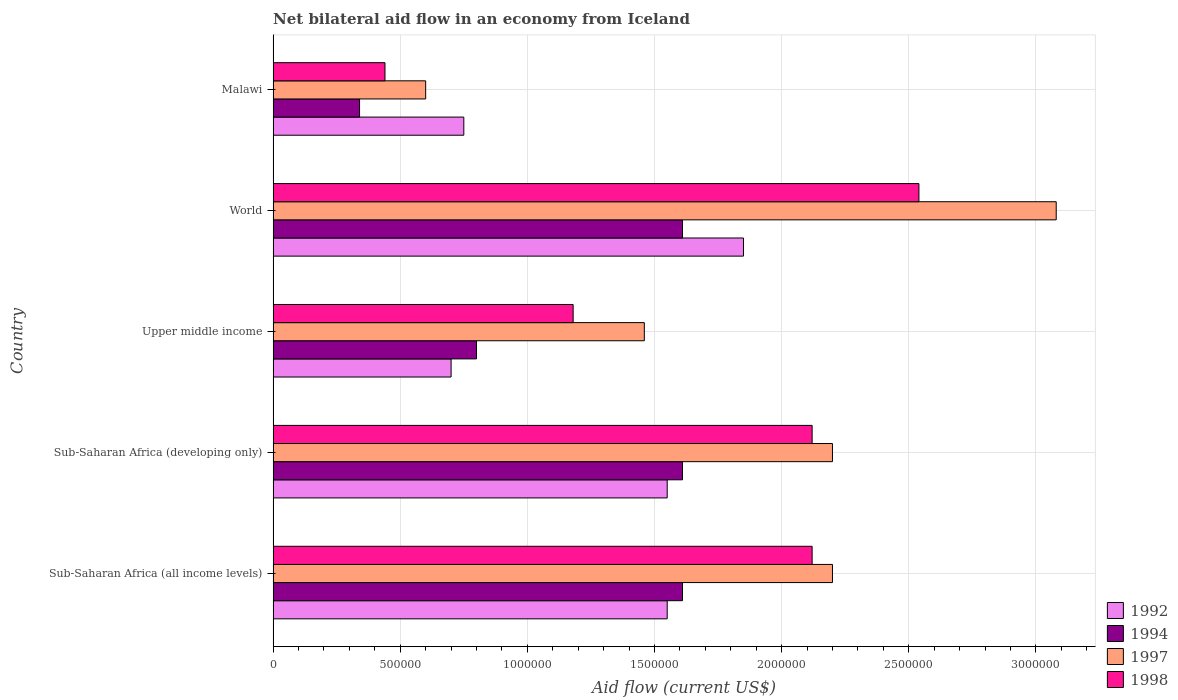How many bars are there on the 5th tick from the top?
Make the answer very short. 4. What is the label of the 4th group of bars from the top?
Offer a very short reply. Sub-Saharan Africa (developing only). Across all countries, what is the maximum net bilateral aid flow in 1998?
Your answer should be compact. 2.54e+06. In which country was the net bilateral aid flow in 1992 minimum?
Keep it short and to the point. Upper middle income. What is the total net bilateral aid flow in 1997 in the graph?
Your response must be concise. 9.54e+06. What is the difference between the net bilateral aid flow in 1998 in Sub-Saharan Africa (developing only) and that in Upper middle income?
Offer a very short reply. 9.40e+05. What is the difference between the net bilateral aid flow in 1997 in Malawi and the net bilateral aid flow in 1992 in World?
Keep it short and to the point. -1.25e+06. What is the average net bilateral aid flow in 1994 per country?
Ensure brevity in your answer.  1.19e+06. In how many countries, is the net bilateral aid flow in 1992 greater than 2400000 US$?
Offer a terse response. 0. What is the ratio of the net bilateral aid flow in 1997 in Malawi to that in Sub-Saharan Africa (developing only)?
Your answer should be very brief. 0.27. Is the net bilateral aid flow in 1997 in Malawi less than that in Sub-Saharan Africa (developing only)?
Offer a terse response. Yes. What is the difference between the highest and the second highest net bilateral aid flow in 1992?
Your answer should be very brief. 3.00e+05. What is the difference between the highest and the lowest net bilateral aid flow in 1994?
Offer a terse response. 1.27e+06. Is it the case that in every country, the sum of the net bilateral aid flow in 1998 and net bilateral aid flow in 1992 is greater than the net bilateral aid flow in 1994?
Ensure brevity in your answer.  Yes. How many countries are there in the graph?
Give a very brief answer. 5. What is the difference between two consecutive major ticks on the X-axis?
Ensure brevity in your answer.  5.00e+05. Are the values on the major ticks of X-axis written in scientific E-notation?
Offer a very short reply. No. Does the graph contain any zero values?
Offer a very short reply. No. How many legend labels are there?
Keep it short and to the point. 4. How are the legend labels stacked?
Your answer should be compact. Vertical. What is the title of the graph?
Offer a terse response. Net bilateral aid flow in an economy from Iceland. What is the label or title of the Y-axis?
Your answer should be very brief. Country. What is the Aid flow (current US$) of 1992 in Sub-Saharan Africa (all income levels)?
Give a very brief answer. 1.55e+06. What is the Aid flow (current US$) in 1994 in Sub-Saharan Africa (all income levels)?
Make the answer very short. 1.61e+06. What is the Aid flow (current US$) of 1997 in Sub-Saharan Africa (all income levels)?
Provide a succinct answer. 2.20e+06. What is the Aid flow (current US$) of 1998 in Sub-Saharan Africa (all income levels)?
Make the answer very short. 2.12e+06. What is the Aid flow (current US$) of 1992 in Sub-Saharan Africa (developing only)?
Offer a terse response. 1.55e+06. What is the Aid flow (current US$) of 1994 in Sub-Saharan Africa (developing only)?
Your response must be concise. 1.61e+06. What is the Aid flow (current US$) of 1997 in Sub-Saharan Africa (developing only)?
Provide a succinct answer. 2.20e+06. What is the Aid flow (current US$) of 1998 in Sub-Saharan Africa (developing only)?
Your answer should be compact. 2.12e+06. What is the Aid flow (current US$) of 1997 in Upper middle income?
Provide a succinct answer. 1.46e+06. What is the Aid flow (current US$) in 1998 in Upper middle income?
Make the answer very short. 1.18e+06. What is the Aid flow (current US$) in 1992 in World?
Offer a terse response. 1.85e+06. What is the Aid flow (current US$) of 1994 in World?
Provide a short and direct response. 1.61e+06. What is the Aid flow (current US$) of 1997 in World?
Your answer should be compact. 3.08e+06. What is the Aid flow (current US$) of 1998 in World?
Provide a short and direct response. 2.54e+06. What is the Aid flow (current US$) in 1992 in Malawi?
Ensure brevity in your answer.  7.50e+05. Across all countries, what is the maximum Aid flow (current US$) in 1992?
Ensure brevity in your answer.  1.85e+06. Across all countries, what is the maximum Aid flow (current US$) in 1994?
Ensure brevity in your answer.  1.61e+06. Across all countries, what is the maximum Aid flow (current US$) in 1997?
Your answer should be compact. 3.08e+06. Across all countries, what is the maximum Aid flow (current US$) in 1998?
Offer a very short reply. 2.54e+06. Across all countries, what is the minimum Aid flow (current US$) of 1992?
Provide a succinct answer. 7.00e+05. Across all countries, what is the minimum Aid flow (current US$) of 1994?
Ensure brevity in your answer.  3.40e+05. Across all countries, what is the minimum Aid flow (current US$) in 1997?
Provide a succinct answer. 6.00e+05. Across all countries, what is the minimum Aid flow (current US$) in 1998?
Your answer should be compact. 4.40e+05. What is the total Aid flow (current US$) in 1992 in the graph?
Provide a short and direct response. 6.40e+06. What is the total Aid flow (current US$) of 1994 in the graph?
Offer a very short reply. 5.97e+06. What is the total Aid flow (current US$) in 1997 in the graph?
Your response must be concise. 9.54e+06. What is the total Aid flow (current US$) of 1998 in the graph?
Keep it short and to the point. 8.40e+06. What is the difference between the Aid flow (current US$) of 1992 in Sub-Saharan Africa (all income levels) and that in Sub-Saharan Africa (developing only)?
Your answer should be compact. 0. What is the difference between the Aid flow (current US$) of 1994 in Sub-Saharan Africa (all income levels) and that in Sub-Saharan Africa (developing only)?
Provide a short and direct response. 0. What is the difference between the Aid flow (current US$) in 1997 in Sub-Saharan Africa (all income levels) and that in Sub-Saharan Africa (developing only)?
Offer a very short reply. 0. What is the difference between the Aid flow (current US$) in 1998 in Sub-Saharan Africa (all income levels) and that in Sub-Saharan Africa (developing only)?
Keep it short and to the point. 0. What is the difference between the Aid flow (current US$) of 1992 in Sub-Saharan Africa (all income levels) and that in Upper middle income?
Ensure brevity in your answer.  8.50e+05. What is the difference between the Aid flow (current US$) in 1994 in Sub-Saharan Africa (all income levels) and that in Upper middle income?
Your answer should be very brief. 8.10e+05. What is the difference between the Aid flow (current US$) of 1997 in Sub-Saharan Africa (all income levels) and that in Upper middle income?
Provide a succinct answer. 7.40e+05. What is the difference between the Aid flow (current US$) in 1998 in Sub-Saharan Africa (all income levels) and that in Upper middle income?
Make the answer very short. 9.40e+05. What is the difference between the Aid flow (current US$) of 1992 in Sub-Saharan Africa (all income levels) and that in World?
Make the answer very short. -3.00e+05. What is the difference between the Aid flow (current US$) of 1997 in Sub-Saharan Africa (all income levels) and that in World?
Provide a succinct answer. -8.80e+05. What is the difference between the Aid flow (current US$) of 1998 in Sub-Saharan Africa (all income levels) and that in World?
Give a very brief answer. -4.20e+05. What is the difference between the Aid flow (current US$) in 1992 in Sub-Saharan Africa (all income levels) and that in Malawi?
Offer a very short reply. 8.00e+05. What is the difference between the Aid flow (current US$) of 1994 in Sub-Saharan Africa (all income levels) and that in Malawi?
Give a very brief answer. 1.27e+06. What is the difference between the Aid flow (current US$) of 1997 in Sub-Saharan Africa (all income levels) and that in Malawi?
Offer a very short reply. 1.60e+06. What is the difference between the Aid flow (current US$) in 1998 in Sub-Saharan Africa (all income levels) and that in Malawi?
Offer a terse response. 1.68e+06. What is the difference between the Aid flow (current US$) in 1992 in Sub-Saharan Africa (developing only) and that in Upper middle income?
Your answer should be compact. 8.50e+05. What is the difference between the Aid flow (current US$) in 1994 in Sub-Saharan Africa (developing only) and that in Upper middle income?
Make the answer very short. 8.10e+05. What is the difference between the Aid flow (current US$) of 1997 in Sub-Saharan Africa (developing only) and that in Upper middle income?
Your answer should be compact. 7.40e+05. What is the difference between the Aid flow (current US$) of 1998 in Sub-Saharan Africa (developing only) and that in Upper middle income?
Keep it short and to the point. 9.40e+05. What is the difference between the Aid flow (current US$) in 1992 in Sub-Saharan Africa (developing only) and that in World?
Your answer should be compact. -3.00e+05. What is the difference between the Aid flow (current US$) in 1997 in Sub-Saharan Africa (developing only) and that in World?
Your answer should be very brief. -8.80e+05. What is the difference between the Aid flow (current US$) in 1998 in Sub-Saharan Africa (developing only) and that in World?
Your answer should be very brief. -4.20e+05. What is the difference between the Aid flow (current US$) in 1994 in Sub-Saharan Africa (developing only) and that in Malawi?
Your answer should be very brief. 1.27e+06. What is the difference between the Aid flow (current US$) of 1997 in Sub-Saharan Africa (developing only) and that in Malawi?
Offer a very short reply. 1.60e+06. What is the difference between the Aid flow (current US$) of 1998 in Sub-Saharan Africa (developing only) and that in Malawi?
Make the answer very short. 1.68e+06. What is the difference between the Aid flow (current US$) of 1992 in Upper middle income and that in World?
Your answer should be very brief. -1.15e+06. What is the difference between the Aid flow (current US$) in 1994 in Upper middle income and that in World?
Offer a terse response. -8.10e+05. What is the difference between the Aid flow (current US$) in 1997 in Upper middle income and that in World?
Provide a short and direct response. -1.62e+06. What is the difference between the Aid flow (current US$) of 1998 in Upper middle income and that in World?
Offer a very short reply. -1.36e+06. What is the difference between the Aid flow (current US$) in 1992 in Upper middle income and that in Malawi?
Provide a short and direct response. -5.00e+04. What is the difference between the Aid flow (current US$) in 1994 in Upper middle income and that in Malawi?
Your response must be concise. 4.60e+05. What is the difference between the Aid flow (current US$) in 1997 in Upper middle income and that in Malawi?
Give a very brief answer. 8.60e+05. What is the difference between the Aid flow (current US$) in 1998 in Upper middle income and that in Malawi?
Your answer should be compact. 7.40e+05. What is the difference between the Aid flow (current US$) of 1992 in World and that in Malawi?
Offer a very short reply. 1.10e+06. What is the difference between the Aid flow (current US$) in 1994 in World and that in Malawi?
Your answer should be compact. 1.27e+06. What is the difference between the Aid flow (current US$) in 1997 in World and that in Malawi?
Keep it short and to the point. 2.48e+06. What is the difference between the Aid flow (current US$) in 1998 in World and that in Malawi?
Your answer should be compact. 2.10e+06. What is the difference between the Aid flow (current US$) in 1992 in Sub-Saharan Africa (all income levels) and the Aid flow (current US$) in 1994 in Sub-Saharan Africa (developing only)?
Provide a short and direct response. -6.00e+04. What is the difference between the Aid flow (current US$) in 1992 in Sub-Saharan Africa (all income levels) and the Aid flow (current US$) in 1997 in Sub-Saharan Africa (developing only)?
Your answer should be very brief. -6.50e+05. What is the difference between the Aid flow (current US$) of 1992 in Sub-Saharan Africa (all income levels) and the Aid flow (current US$) of 1998 in Sub-Saharan Africa (developing only)?
Offer a terse response. -5.70e+05. What is the difference between the Aid flow (current US$) of 1994 in Sub-Saharan Africa (all income levels) and the Aid flow (current US$) of 1997 in Sub-Saharan Africa (developing only)?
Your answer should be compact. -5.90e+05. What is the difference between the Aid flow (current US$) of 1994 in Sub-Saharan Africa (all income levels) and the Aid flow (current US$) of 1998 in Sub-Saharan Africa (developing only)?
Provide a short and direct response. -5.10e+05. What is the difference between the Aid flow (current US$) in 1992 in Sub-Saharan Africa (all income levels) and the Aid flow (current US$) in 1994 in Upper middle income?
Offer a terse response. 7.50e+05. What is the difference between the Aid flow (current US$) of 1992 in Sub-Saharan Africa (all income levels) and the Aid flow (current US$) of 1997 in Upper middle income?
Ensure brevity in your answer.  9.00e+04. What is the difference between the Aid flow (current US$) in 1992 in Sub-Saharan Africa (all income levels) and the Aid flow (current US$) in 1998 in Upper middle income?
Provide a succinct answer. 3.70e+05. What is the difference between the Aid flow (current US$) in 1997 in Sub-Saharan Africa (all income levels) and the Aid flow (current US$) in 1998 in Upper middle income?
Provide a succinct answer. 1.02e+06. What is the difference between the Aid flow (current US$) in 1992 in Sub-Saharan Africa (all income levels) and the Aid flow (current US$) in 1997 in World?
Your answer should be very brief. -1.53e+06. What is the difference between the Aid flow (current US$) in 1992 in Sub-Saharan Africa (all income levels) and the Aid flow (current US$) in 1998 in World?
Your answer should be compact. -9.90e+05. What is the difference between the Aid flow (current US$) in 1994 in Sub-Saharan Africa (all income levels) and the Aid flow (current US$) in 1997 in World?
Your response must be concise. -1.47e+06. What is the difference between the Aid flow (current US$) in 1994 in Sub-Saharan Africa (all income levels) and the Aid flow (current US$) in 1998 in World?
Provide a succinct answer. -9.30e+05. What is the difference between the Aid flow (current US$) of 1992 in Sub-Saharan Africa (all income levels) and the Aid flow (current US$) of 1994 in Malawi?
Your answer should be very brief. 1.21e+06. What is the difference between the Aid flow (current US$) in 1992 in Sub-Saharan Africa (all income levels) and the Aid flow (current US$) in 1997 in Malawi?
Your response must be concise. 9.50e+05. What is the difference between the Aid flow (current US$) in 1992 in Sub-Saharan Africa (all income levels) and the Aid flow (current US$) in 1998 in Malawi?
Your answer should be compact. 1.11e+06. What is the difference between the Aid flow (current US$) of 1994 in Sub-Saharan Africa (all income levels) and the Aid flow (current US$) of 1997 in Malawi?
Your answer should be very brief. 1.01e+06. What is the difference between the Aid flow (current US$) in 1994 in Sub-Saharan Africa (all income levels) and the Aid flow (current US$) in 1998 in Malawi?
Your response must be concise. 1.17e+06. What is the difference between the Aid flow (current US$) of 1997 in Sub-Saharan Africa (all income levels) and the Aid flow (current US$) of 1998 in Malawi?
Provide a succinct answer. 1.76e+06. What is the difference between the Aid flow (current US$) in 1992 in Sub-Saharan Africa (developing only) and the Aid flow (current US$) in 1994 in Upper middle income?
Keep it short and to the point. 7.50e+05. What is the difference between the Aid flow (current US$) in 1992 in Sub-Saharan Africa (developing only) and the Aid flow (current US$) in 1997 in Upper middle income?
Provide a short and direct response. 9.00e+04. What is the difference between the Aid flow (current US$) of 1992 in Sub-Saharan Africa (developing only) and the Aid flow (current US$) of 1998 in Upper middle income?
Offer a terse response. 3.70e+05. What is the difference between the Aid flow (current US$) in 1994 in Sub-Saharan Africa (developing only) and the Aid flow (current US$) in 1997 in Upper middle income?
Make the answer very short. 1.50e+05. What is the difference between the Aid flow (current US$) in 1997 in Sub-Saharan Africa (developing only) and the Aid flow (current US$) in 1998 in Upper middle income?
Ensure brevity in your answer.  1.02e+06. What is the difference between the Aid flow (current US$) in 1992 in Sub-Saharan Africa (developing only) and the Aid flow (current US$) in 1997 in World?
Ensure brevity in your answer.  -1.53e+06. What is the difference between the Aid flow (current US$) in 1992 in Sub-Saharan Africa (developing only) and the Aid flow (current US$) in 1998 in World?
Give a very brief answer. -9.90e+05. What is the difference between the Aid flow (current US$) of 1994 in Sub-Saharan Africa (developing only) and the Aid flow (current US$) of 1997 in World?
Your response must be concise. -1.47e+06. What is the difference between the Aid flow (current US$) of 1994 in Sub-Saharan Africa (developing only) and the Aid flow (current US$) of 1998 in World?
Offer a very short reply. -9.30e+05. What is the difference between the Aid flow (current US$) of 1997 in Sub-Saharan Africa (developing only) and the Aid flow (current US$) of 1998 in World?
Offer a terse response. -3.40e+05. What is the difference between the Aid flow (current US$) in 1992 in Sub-Saharan Africa (developing only) and the Aid flow (current US$) in 1994 in Malawi?
Your response must be concise. 1.21e+06. What is the difference between the Aid flow (current US$) of 1992 in Sub-Saharan Africa (developing only) and the Aid flow (current US$) of 1997 in Malawi?
Your response must be concise. 9.50e+05. What is the difference between the Aid flow (current US$) in 1992 in Sub-Saharan Africa (developing only) and the Aid flow (current US$) in 1998 in Malawi?
Provide a short and direct response. 1.11e+06. What is the difference between the Aid flow (current US$) in 1994 in Sub-Saharan Africa (developing only) and the Aid flow (current US$) in 1997 in Malawi?
Provide a succinct answer. 1.01e+06. What is the difference between the Aid flow (current US$) in 1994 in Sub-Saharan Africa (developing only) and the Aid flow (current US$) in 1998 in Malawi?
Make the answer very short. 1.17e+06. What is the difference between the Aid flow (current US$) of 1997 in Sub-Saharan Africa (developing only) and the Aid flow (current US$) of 1998 in Malawi?
Make the answer very short. 1.76e+06. What is the difference between the Aid flow (current US$) in 1992 in Upper middle income and the Aid flow (current US$) in 1994 in World?
Your response must be concise. -9.10e+05. What is the difference between the Aid flow (current US$) of 1992 in Upper middle income and the Aid flow (current US$) of 1997 in World?
Offer a terse response. -2.38e+06. What is the difference between the Aid flow (current US$) in 1992 in Upper middle income and the Aid flow (current US$) in 1998 in World?
Provide a succinct answer. -1.84e+06. What is the difference between the Aid flow (current US$) in 1994 in Upper middle income and the Aid flow (current US$) in 1997 in World?
Provide a succinct answer. -2.28e+06. What is the difference between the Aid flow (current US$) in 1994 in Upper middle income and the Aid flow (current US$) in 1998 in World?
Ensure brevity in your answer.  -1.74e+06. What is the difference between the Aid flow (current US$) in 1997 in Upper middle income and the Aid flow (current US$) in 1998 in World?
Your answer should be compact. -1.08e+06. What is the difference between the Aid flow (current US$) in 1992 in Upper middle income and the Aid flow (current US$) in 1994 in Malawi?
Make the answer very short. 3.60e+05. What is the difference between the Aid flow (current US$) of 1992 in Upper middle income and the Aid flow (current US$) of 1998 in Malawi?
Your response must be concise. 2.60e+05. What is the difference between the Aid flow (current US$) of 1994 in Upper middle income and the Aid flow (current US$) of 1997 in Malawi?
Keep it short and to the point. 2.00e+05. What is the difference between the Aid flow (current US$) in 1997 in Upper middle income and the Aid flow (current US$) in 1998 in Malawi?
Your answer should be very brief. 1.02e+06. What is the difference between the Aid flow (current US$) in 1992 in World and the Aid flow (current US$) in 1994 in Malawi?
Make the answer very short. 1.51e+06. What is the difference between the Aid flow (current US$) of 1992 in World and the Aid flow (current US$) of 1997 in Malawi?
Ensure brevity in your answer.  1.25e+06. What is the difference between the Aid flow (current US$) in 1992 in World and the Aid flow (current US$) in 1998 in Malawi?
Keep it short and to the point. 1.41e+06. What is the difference between the Aid flow (current US$) of 1994 in World and the Aid flow (current US$) of 1997 in Malawi?
Your answer should be compact. 1.01e+06. What is the difference between the Aid flow (current US$) in 1994 in World and the Aid flow (current US$) in 1998 in Malawi?
Offer a terse response. 1.17e+06. What is the difference between the Aid flow (current US$) in 1997 in World and the Aid flow (current US$) in 1998 in Malawi?
Offer a terse response. 2.64e+06. What is the average Aid flow (current US$) in 1992 per country?
Make the answer very short. 1.28e+06. What is the average Aid flow (current US$) in 1994 per country?
Offer a very short reply. 1.19e+06. What is the average Aid flow (current US$) of 1997 per country?
Your answer should be very brief. 1.91e+06. What is the average Aid flow (current US$) in 1998 per country?
Offer a terse response. 1.68e+06. What is the difference between the Aid flow (current US$) of 1992 and Aid flow (current US$) of 1997 in Sub-Saharan Africa (all income levels)?
Make the answer very short. -6.50e+05. What is the difference between the Aid flow (current US$) of 1992 and Aid flow (current US$) of 1998 in Sub-Saharan Africa (all income levels)?
Your answer should be compact. -5.70e+05. What is the difference between the Aid flow (current US$) in 1994 and Aid flow (current US$) in 1997 in Sub-Saharan Africa (all income levels)?
Your answer should be compact. -5.90e+05. What is the difference between the Aid flow (current US$) in 1994 and Aid flow (current US$) in 1998 in Sub-Saharan Africa (all income levels)?
Your answer should be very brief. -5.10e+05. What is the difference between the Aid flow (current US$) of 1992 and Aid flow (current US$) of 1994 in Sub-Saharan Africa (developing only)?
Your answer should be very brief. -6.00e+04. What is the difference between the Aid flow (current US$) in 1992 and Aid flow (current US$) in 1997 in Sub-Saharan Africa (developing only)?
Offer a terse response. -6.50e+05. What is the difference between the Aid flow (current US$) in 1992 and Aid flow (current US$) in 1998 in Sub-Saharan Africa (developing only)?
Your response must be concise. -5.70e+05. What is the difference between the Aid flow (current US$) of 1994 and Aid flow (current US$) of 1997 in Sub-Saharan Africa (developing only)?
Provide a succinct answer. -5.90e+05. What is the difference between the Aid flow (current US$) in 1994 and Aid flow (current US$) in 1998 in Sub-Saharan Africa (developing only)?
Make the answer very short. -5.10e+05. What is the difference between the Aid flow (current US$) of 1992 and Aid flow (current US$) of 1994 in Upper middle income?
Keep it short and to the point. -1.00e+05. What is the difference between the Aid flow (current US$) in 1992 and Aid flow (current US$) in 1997 in Upper middle income?
Provide a succinct answer. -7.60e+05. What is the difference between the Aid flow (current US$) of 1992 and Aid flow (current US$) of 1998 in Upper middle income?
Your answer should be very brief. -4.80e+05. What is the difference between the Aid flow (current US$) of 1994 and Aid flow (current US$) of 1997 in Upper middle income?
Your response must be concise. -6.60e+05. What is the difference between the Aid flow (current US$) of 1994 and Aid flow (current US$) of 1998 in Upper middle income?
Your answer should be very brief. -3.80e+05. What is the difference between the Aid flow (current US$) in 1997 and Aid flow (current US$) in 1998 in Upper middle income?
Offer a terse response. 2.80e+05. What is the difference between the Aid flow (current US$) of 1992 and Aid flow (current US$) of 1994 in World?
Ensure brevity in your answer.  2.40e+05. What is the difference between the Aid flow (current US$) in 1992 and Aid flow (current US$) in 1997 in World?
Make the answer very short. -1.23e+06. What is the difference between the Aid flow (current US$) of 1992 and Aid flow (current US$) of 1998 in World?
Provide a short and direct response. -6.90e+05. What is the difference between the Aid flow (current US$) of 1994 and Aid flow (current US$) of 1997 in World?
Your response must be concise. -1.47e+06. What is the difference between the Aid flow (current US$) in 1994 and Aid flow (current US$) in 1998 in World?
Ensure brevity in your answer.  -9.30e+05. What is the difference between the Aid flow (current US$) of 1997 and Aid flow (current US$) of 1998 in World?
Ensure brevity in your answer.  5.40e+05. What is the difference between the Aid flow (current US$) of 1992 and Aid flow (current US$) of 1994 in Malawi?
Make the answer very short. 4.10e+05. What is the difference between the Aid flow (current US$) in 1992 and Aid flow (current US$) in 1998 in Malawi?
Your answer should be compact. 3.10e+05. What is the difference between the Aid flow (current US$) of 1994 and Aid flow (current US$) of 1997 in Malawi?
Make the answer very short. -2.60e+05. What is the difference between the Aid flow (current US$) of 1997 and Aid flow (current US$) of 1998 in Malawi?
Your answer should be compact. 1.60e+05. What is the ratio of the Aid flow (current US$) of 1992 in Sub-Saharan Africa (all income levels) to that in Sub-Saharan Africa (developing only)?
Your answer should be compact. 1. What is the ratio of the Aid flow (current US$) in 1994 in Sub-Saharan Africa (all income levels) to that in Sub-Saharan Africa (developing only)?
Make the answer very short. 1. What is the ratio of the Aid flow (current US$) of 1992 in Sub-Saharan Africa (all income levels) to that in Upper middle income?
Offer a very short reply. 2.21. What is the ratio of the Aid flow (current US$) in 1994 in Sub-Saharan Africa (all income levels) to that in Upper middle income?
Keep it short and to the point. 2.01. What is the ratio of the Aid flow (current US$) of 1997 in Sub-Saharan Africa (all income levels) to that in Upper middle income?
Offer a very short reply. 1.51. What is the ratio of the Aid flow (current US$) in 1998 in Sub-Saharan Africa (all income levels) to that in Upper middle income?
Offer a terse response. 1.8. What is the ratio of the Aid flow (current US$) of 1992 in Sub-Saharan Africa (all income levels) to that in World?
Offer a terse response. 0.84. What is the ratio of the Aid flow (current US$) in 1994 in Sub-Saharan Africa (all income levels) to that in World?
Keep it short and to the point. 1. What is the ratio of the Aid flow (current US$) of 1998 in Sub-Saharan Africa (all income levels) to that in World?
Make the answer very short. 0.83. What is the ratio of the Aid flow (current US$) in 1992 in Sub-Saharan Africa (all income levels) to that in Malawi?
Your response must be concise. 2.07. What is the ratio of the Aid flow (current US$) in 1994 in Sub-Saharan Africa (all income levels) to that in Malawi?
Make the answer very short. 4.74. What is the ratio of the Aid flow (current US$) in 1997 in Sub-Saharan Africa (all income levels) to that in Malawi?
Your answer should be compact. 3.67. What is the ratio of the Aid flow (current US$) of 1998 in Sub-Saharan Africa (all income levels) to that in Malawi?
Make the answer very short. 4.82. What is the ratio of the Aid flow (current US$) in 1992 in Sub-Saharan Africa (developing only) to that in Upper middle income?
Offer a terse response. 2.21. What is the ratio of the Aid flow (current US$) in 1994 in Sub-Saharan Africa (developing only) to that in Upper middle income?
Your response must be concise. 2.01. What is the ratio of the Aid flow (current US$) of 1997 in Sub-Saharan Africa (developing only) to that in Upper middle income?
Provide a short and direct response. 1.51. What is the ratio of the Aid flow (current US$) in 1998 in Sub-Saharan Africa (developing only) to that in Upper middle income?
Give a very brief answer. 1.8. What is the ratio of the Aid flow (current US$) in 1992 in Sub-Saharan Africa (developing only) to that in World?
Your response must be concise. 0.84. What is the ratio of the Aid flow (current US$) in 1994 in Sub-Saharan Africa (developing only) to that in World?
Your answer should be compact. 1. What is the ratio of the Aid flow (current US$) in 1997 in Sub-Saharan Africa (developing only) to that in World?
Provide a succinct answer. 0.71. What is the ratio of the Aid flow (current US$) of 1998 in Sub-Saharan Africa (developing only) to that in World?
Give a very brief answer. 0.83. What is the ratio of the Aid flow (current US$) in 1992 in Sub-Saharan Africa (developing only) to that in Malawi?
Offer a very short reply. 2.07. What is the ratio of the Aid flow (current US$) of 1994 in Sub-Saharan Africa (developing only) to that in Malawi?
Your response must be concise. 4.74. What is the ratio of the Aid flow (current US$) of 1997 in Sub-Saharan Africa (developing only) to that in Malawi?
Offer a terse response. 3.67. What is the ratio of the Aid flow (current US$) of 1998 in Sub-Saharan Africa (developing only) to that in Malawi?
Keep it short and to the point. 4.82. What is the ratio of the Aid flow (current US$) in 1992 in Upper middle income to that in World?
Your response must be concise. 0.38. What is the ratio of the Aid flow (current US$) of 1994 in Upper middle income to that in World?
Your response must be concise. 0.5. What is the ratio of the Aid flow (current US$) in 1997 in Upper middle income to that in World?
Offer a terse response. 0.47. What is the ratio of the Aid flow (current US$) in 1998 in Upper middle income to that in World?
Offer a very short reply. 0.46. What is the ratio of the Aid flow (current US$) in 1992 in Upper middle income to that in Malawi?
Provide a short and direct response. 0.93. What is the ratio of the Aid flow (current US$) of 1994 in Upper middle income to that in Malawi?
Offer a terse response. 2.35. What is the ratio of the Aid flow (current US$) of 1997 in Upper middle income to that in Malawi?
Ensure brevity in your answer.  2.43. What is the ratio of the Aid flow (current US$) in 1998 in Upper middle income to that in Malawi?
Your answer should be very brief. 2.68. What is the ratio of the Aid flow (current US$) of 1992 in World to that in Malawi?
Provide a succinct answer. 2.47. What is the ratio of the Aid flow (current US$) of 1994 in World to that in Malawi?
Your answer should be very brief. 4.74. What is the ratio of the Aid flow (current US$) in 1997 in World to that in Malawi?
Offer a very short reply. 5.13. What is the ratio of the Aid flow (current US$) in 1998 in World to that in Malawi?
Provide a short and direct response. 5.77. What is the difference between the highest and the second highest Aid flow (current US$) of 1994?
Ensure brevity in your answer.  0. What is the difference between the highest and the second highest Aid flow (current US$) in 1997?
Offer a terse response. 8.80e+05. What is the difference between the highest and the lowest Aid flow (current US$) in 1992?
Give a very brief answer. 1.15e+06. What is the difference between the highest and the lowest Aid flow (current US$) in 1994?
Offer a very short reply. 1.27e+06. What is the difference between the highest and the lowest Aid flow (current US$) in 1997?
Your answer should be very brief. 2.48e+06. What is the difference between the highest and the lowest Aid flow (current US$) in 1998?
Your response must be concise. 2.10e+06. 